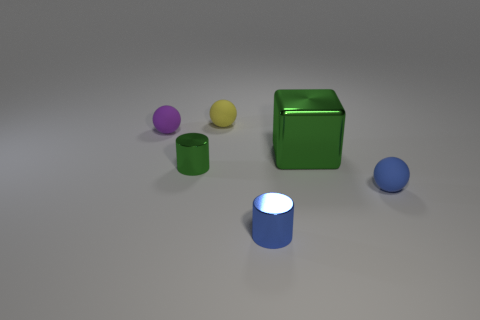Add 2 tiny green objects. How many objects exist? 8 Add 4 green metal objects. How many green metal objects exist? 6 Subtract 1 blue spheres. How many objects are left? 5 Subtract all cylinders. How many objects are left? 4 Subtract all green rubber objects. Subtract all blue metal objects. How many objects are left? 5 Add 3 small metallic things. How many small metallic things are left? 5 